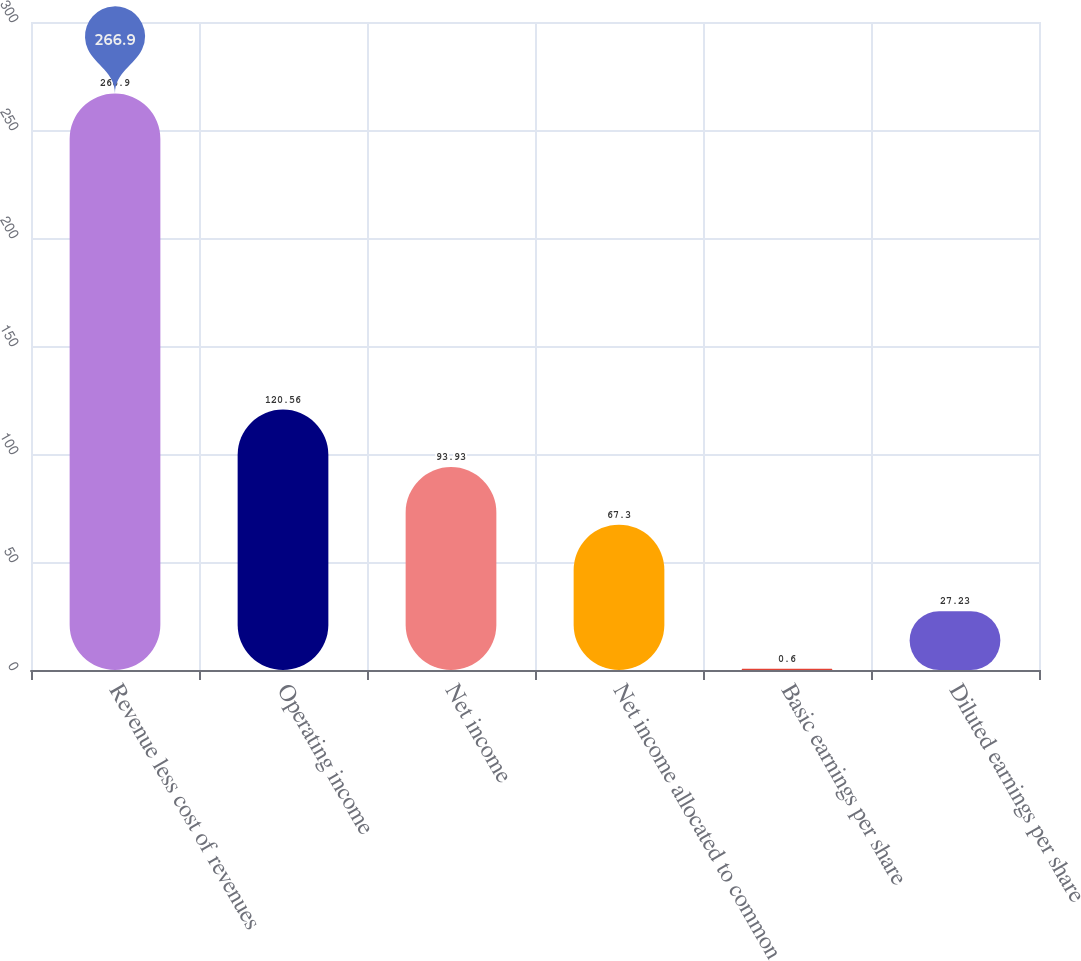Convert chart. <chart><loc_0><loc_0><loc_500><loc_500><bar_chart><fcel>Revenue less cost of revenues<fcel>Operating income<fcel>Net income<fcel>Net income allocated to common<fcel>Basic earnings per share<fcel>Diluted earnings per share<nl><fcel>266.9<fcel>120.56<fcel>93.93<fcel>67.3<fcel>0.6<fcel>27.23<nl></chart> 